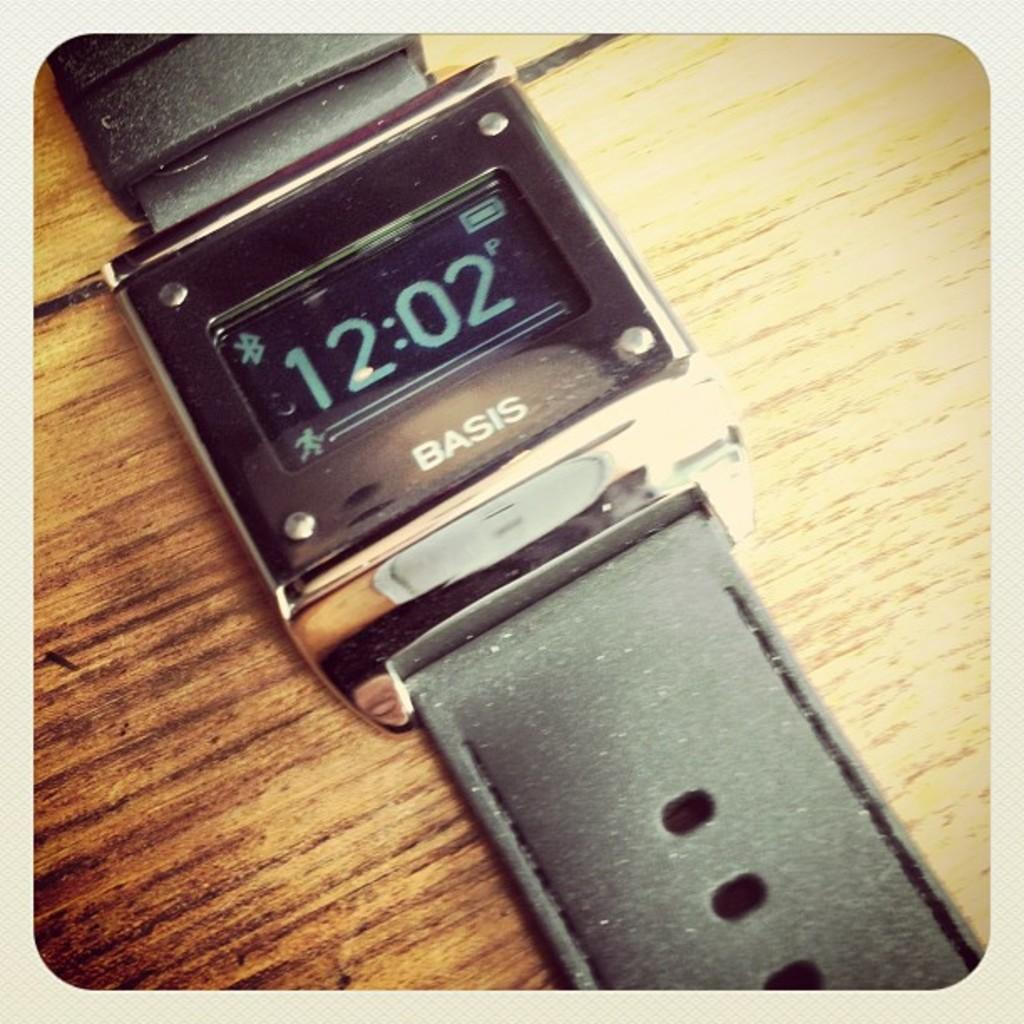<image>
Describe the image concisely. A Basis watch set to the current time of 12:02. 